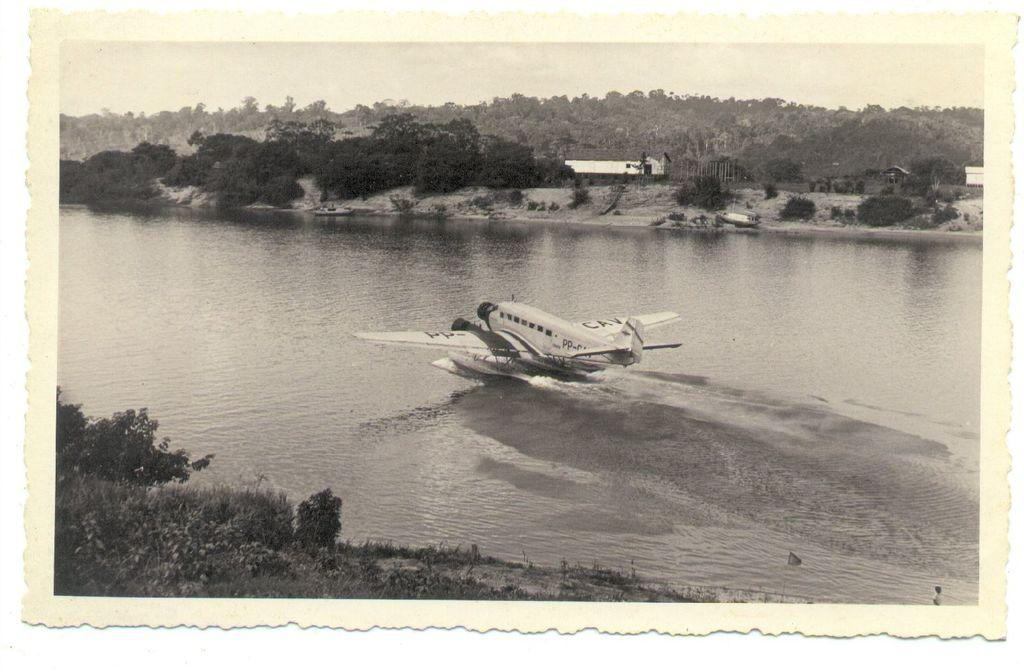What type of vehicle is in the river in the image? There is a ship plane in the river in the image. What natural elements can be seen in the image? There are trees visible in the image. What type of structures are present in the image? There are houses in the image. What type of match is being played in the image? There is no match being played in the image; it features a ship plane in the river, trees, and houses. What type of grain can be seen growing in the image? There is no grain visible in the image. 